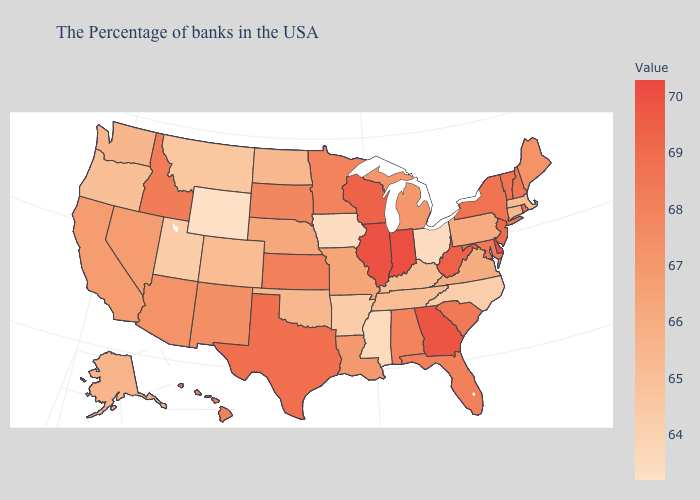Does Vermont have the lowest value in the Northeast?
Short answer required. No. Does Wyoming have the lowest value in the USA?
Write a very short answer. Yes. Among the states that border Connecticut , does Rhode Island have the lowest value?
Be succinct. No. 